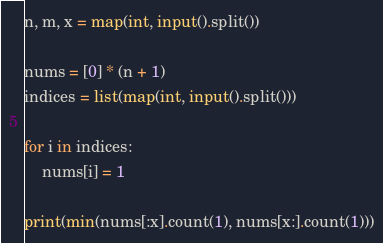<code> <loc_0><loc_0><loc_500><loc_500><_Python_>n, m, x = map(int, input().split())

nums = [0] * (n + 1)
indices = list(map(int, input().split()))

for i in indices:
    nums[i] = 1

print(min(nums[:x].count(1), nums[x:].count(1)))
</code> 